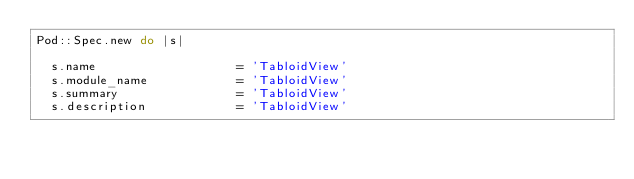Convert code to text. <code><loc_0><loc_0><loc_500><loc_500><_Ruby_>Pod::Spec.new do |s|
  
  s.name                   = 'TabloidView'
  s.module_name            = 'TabloidView'
  s.summary                = 'TabloidView'
  s.description            = 'TabloidView'</code> 